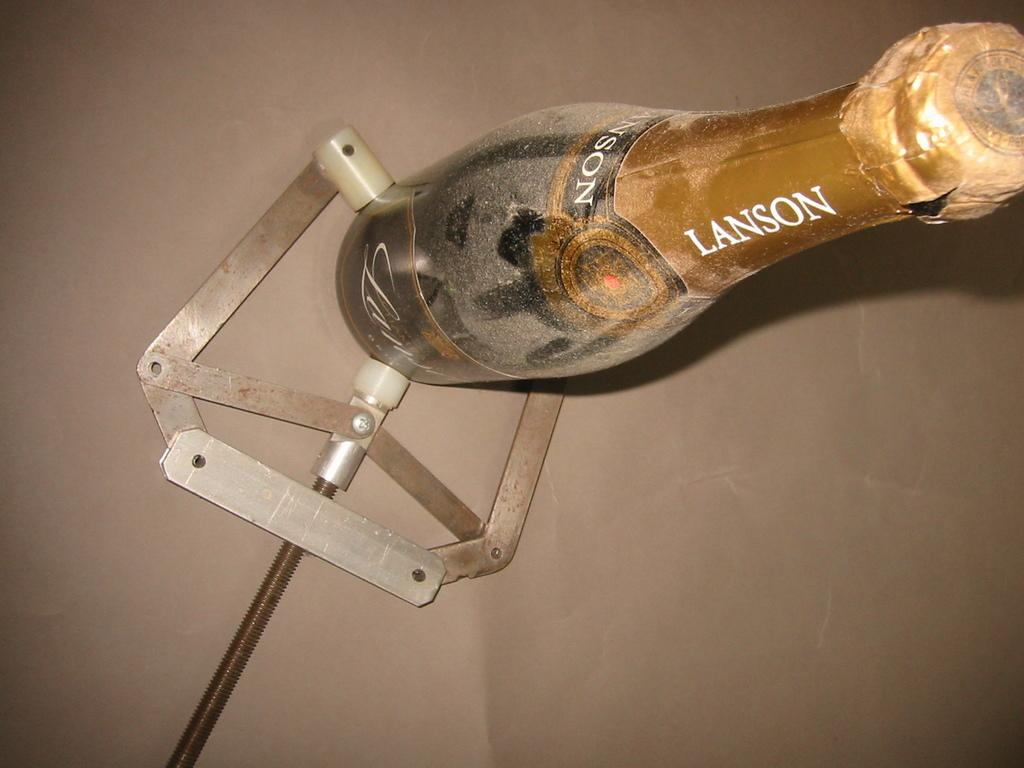<image>
Describe the image concisely. A bottle of Lanson champagne being held by a clamp-like utensil 